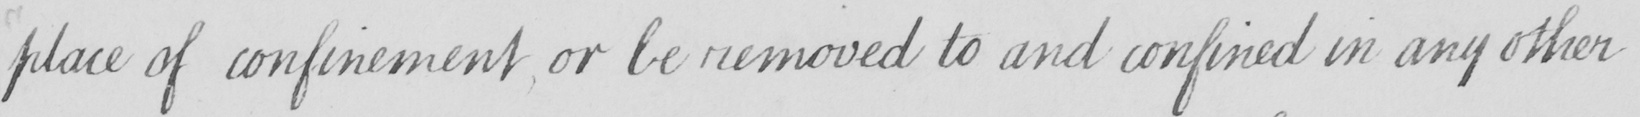What is written in this line of handwriting? place of confinement or be removed to and confined in any other 